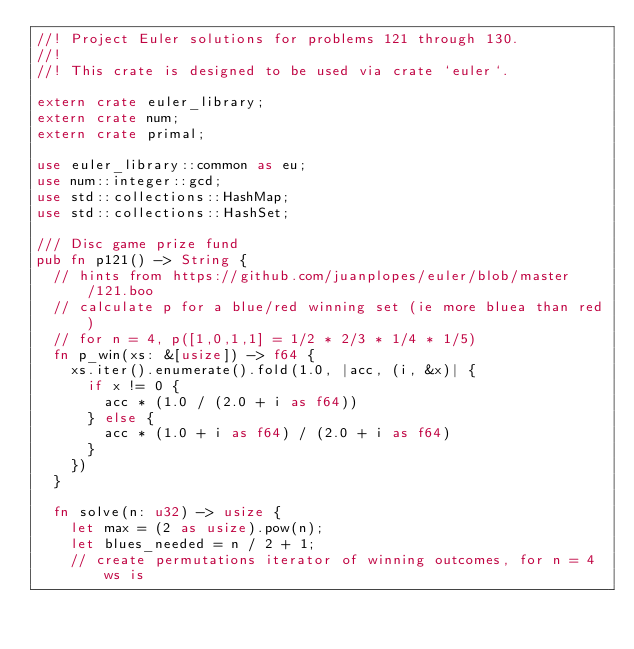Convert code to text. <code><loc_0><loc_0><loc_500><loc_500><_Rust_>//! Project Euler solutions for problems 121 through 130.
//!
//! This crate is designed to be used via crate `euler`.

extern crate euler_library;
extern crate num;
extern crate primal;

use euler_library::common as eu;
use num::integer::gcd;
use std::collections::HashMap;
use std::collections::HashSet;

/// Disc game prize fund
pub fn p121() -> String {
  // hints from https://github.com/juanplopes/euler/blob/master/121.boo
  // calculate p for a blue/red winning set (ie more bluea than red)
  // for n = 4, p([1,0,1,1] = 1/2 * 2/3 * 1/4 * 1/5)
  fn p_win(xs: &[usize]) -> f64 {
    xs.iter().enumerate().fold(1.0, |acc, (i, &x)| {
      if x != 0 {
        acc * (1.0 / (2.0 + i as f64))
      } else {
        acc * (1.0 + i as f64) / (2.0 + i as f64)
      }
    })
  }

  fn solve(n: u32) -> usize {
    let max = (2 as usize).pow(n);
    let blues_needed = n / 2 + 1;
    // create permutations iterator of winning outcomes, for n = 4 ws is</code> 